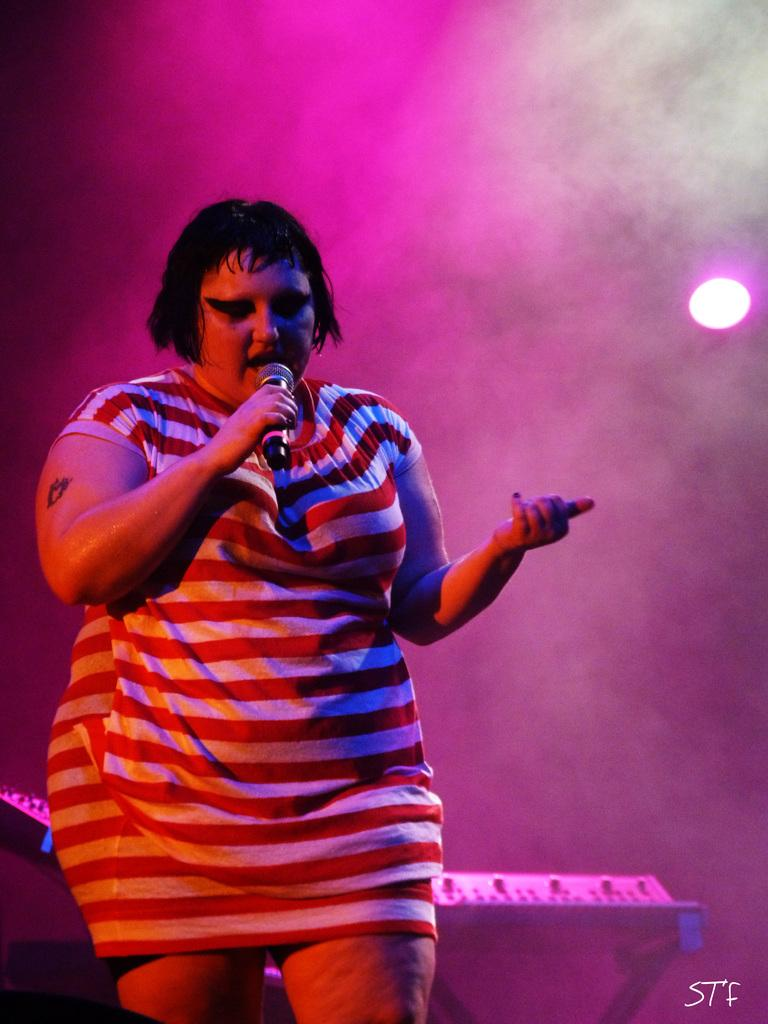Who is the main subject in the image? There is a woman in the image. What is the woman doing in the image? The woman is standing and holding a microphone. What can be seen in the background of the image? There is a light in the background of the image. What else is visible in the image? There is smoke visible in the image, and there is some text at the right bottom of the image. What type of bean is being discussed in the conversation with the woman's friends in the image? There is no conversation with friends present in the image, nor is there any mention of beans. 